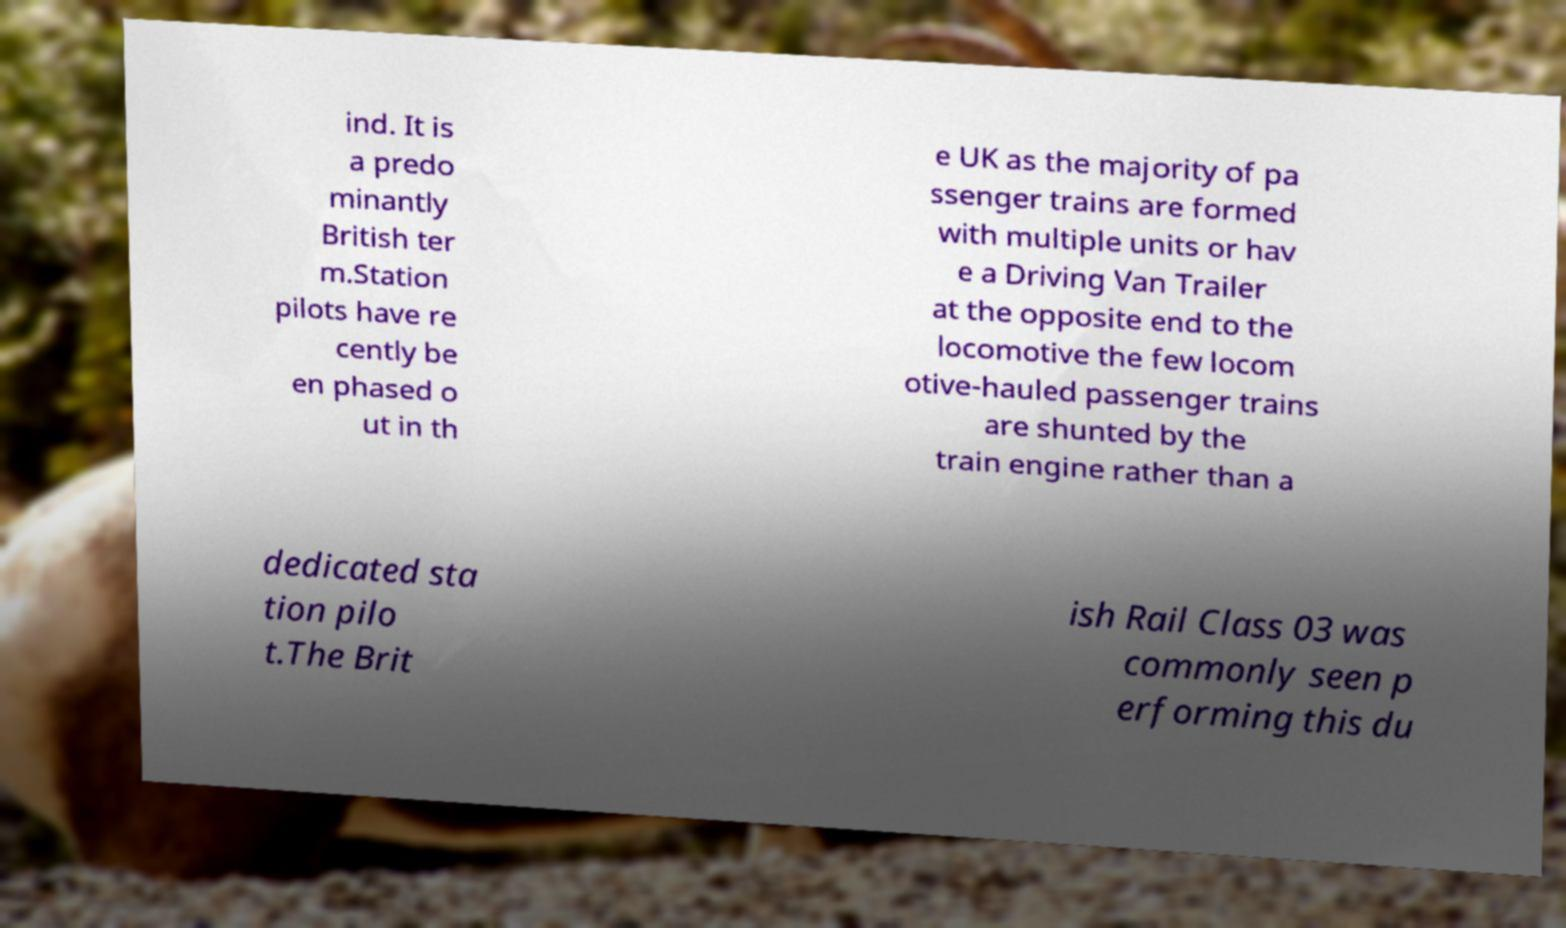For documentation purposes, I need the text within this image transcribed. Could you provide that? ind. It is a predo minantly British ter m.Station pilots have re cently be en phased o ut in th e UK as the majority of pa ssenger trains are formed with multiple units or hav e a Driving Van Trailer at the opposite end to the locomotive the few locom otive-hauled passenger trains are shunted by the train engine rather than a dedicated sta tion pilo t.The Brit ish Rail Class 03 was commonly seen p erforming this du 